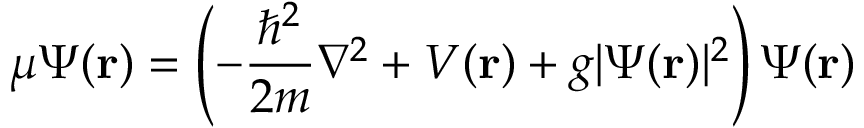<formula> <loc_0><loc_0><loc_500><loc_500>\mu \Psi ( r ) = \left ( - { \frac { \hbar { ^ } { 2 } } { 2 m } } \nabla ^ { 2 } + V ( r ) + g | \Psi ( r ) | ^ { 2 } \right ) \Psi ( r )</formula> 